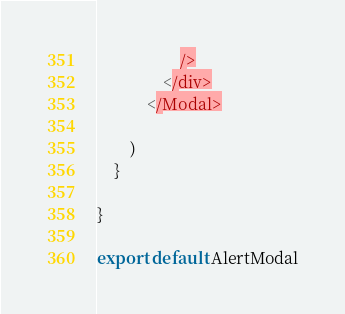Convert code to text. <code><loc_0><loc_0><loc_500><loc_500><_JavaScript_>                    />
                </div>
            </Modal>

        )
    }

}

export default AlertModal</code> 